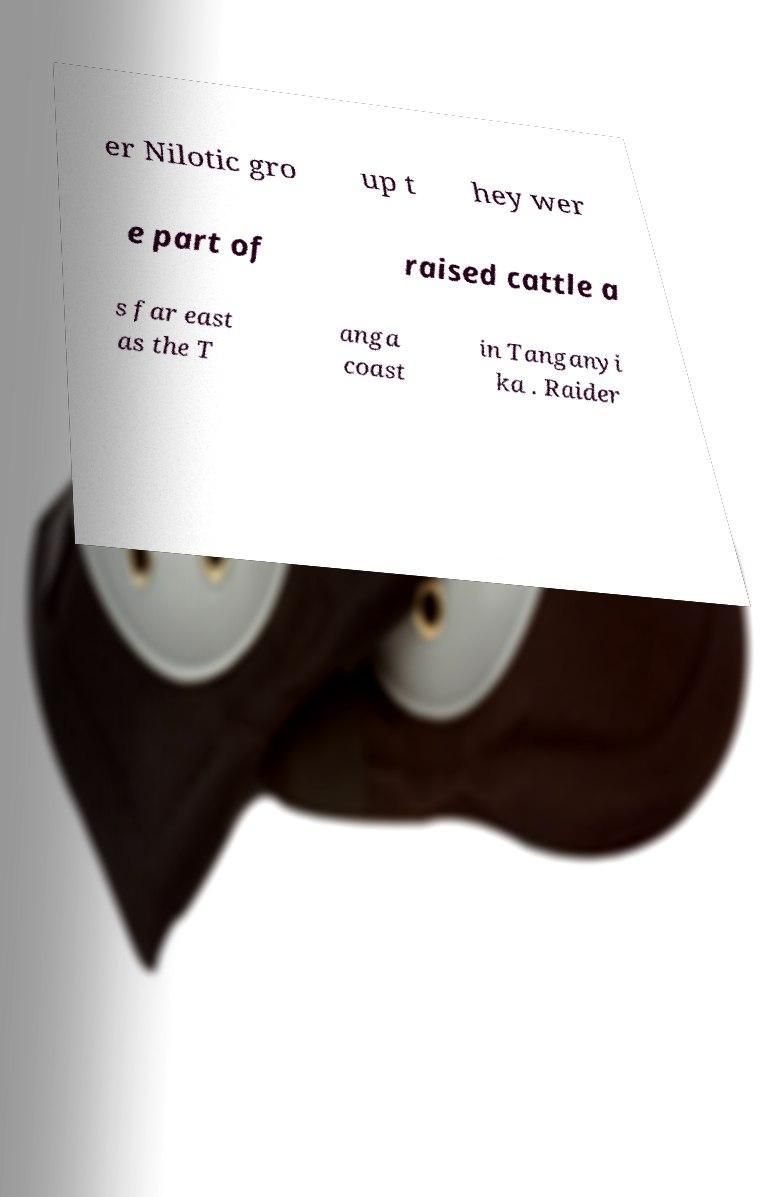Could you assist in decoding the text presented in this image and type it out clearly? er Nilotic gro up t hey wer e part of raised cattle a s far east as the T anga coast in Tanganyi ka . Raider 